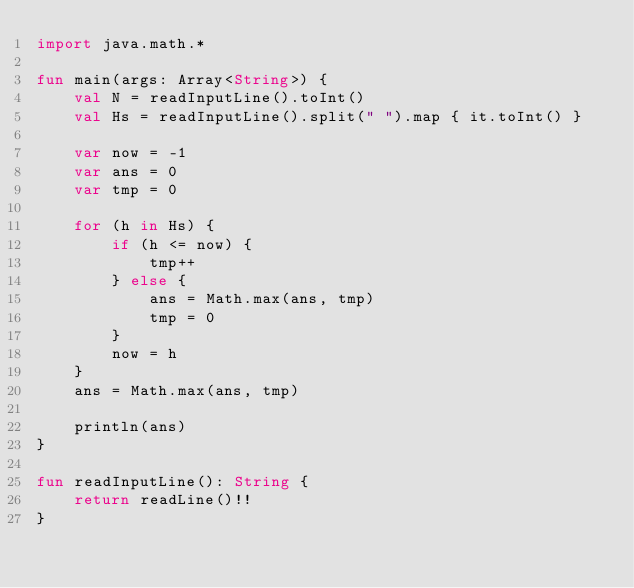Convert code to text. <code><loc_0><loc_0><loc_500><loc_500><_Kotlin_>import java.math.*

fun main(args: Array<String>) {
    val N = readInputLine().toInt()
    val Hs = readInputLine().split(" ").map { it.toInt() }
    
    var now = -1
    var ans = 0
    var tmp = 0
    
    for (h in Hs) {
        if (h <= now) {
            tmp++
        } else {
            ans = Math.max(ans, tmp)
            tmp = 0
        }
        now = h
    }
    ans = Math.max(ans, tmp)

    println(ans)
}

fun readInputLine(): String {
    return readLine()!!
}
</code> 